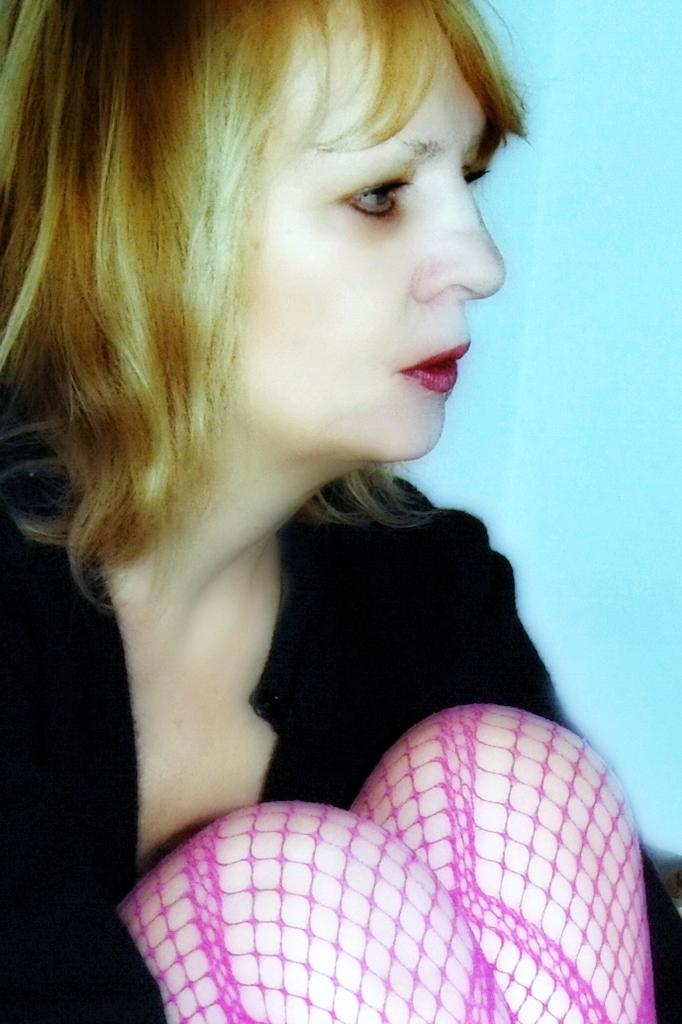Who is the main subject in the image? There is a woman in the image. Where is the woman located in the image? The woman is in the front of the image. How many sheep are visible in the image? There are no sheep present in the image. What is the condition of the woman's health in the image? The image does not provide any information about the woman's health condition. 